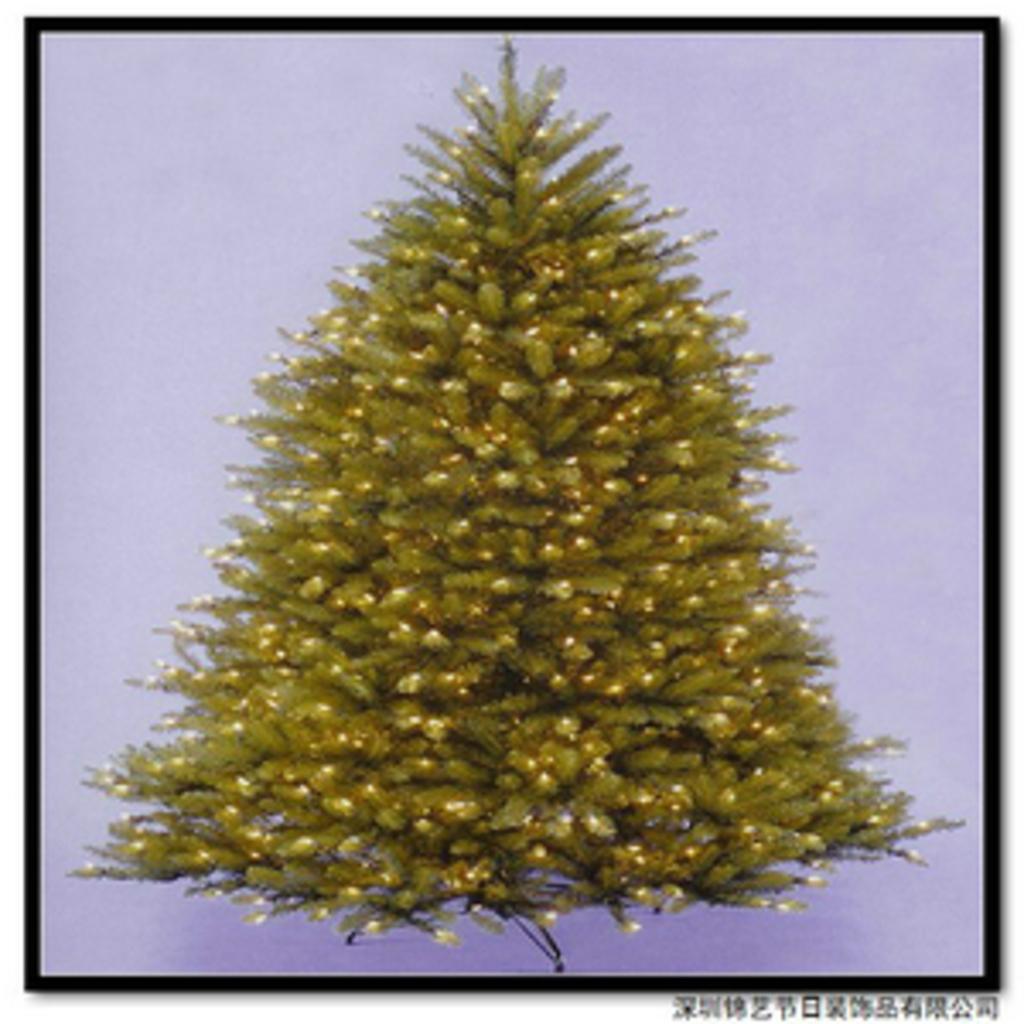Can you describe this image briefly? In this image there is a Christmas tree in the center. 